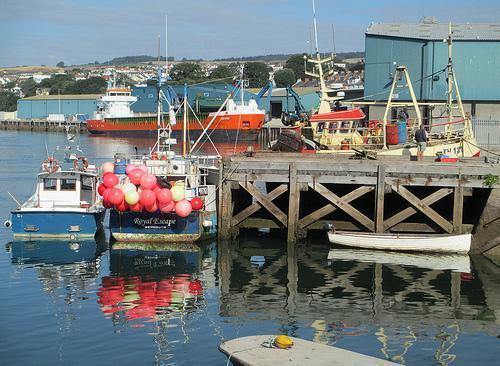How many boats are beside the dock?
Give a very brief answer. 2. 